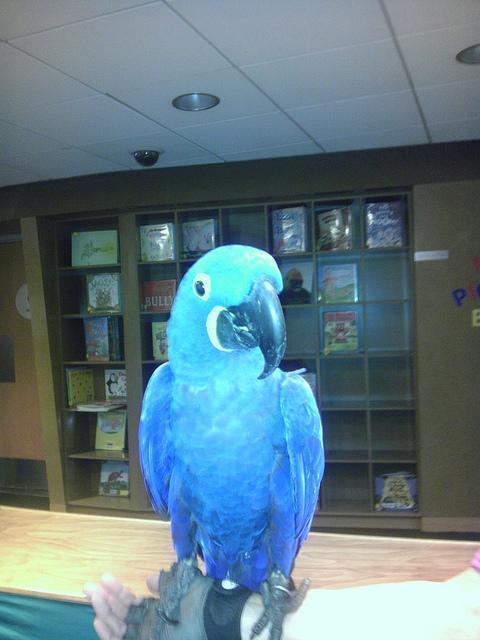Is "The person is touching the bird." an appropriate description for the image?
Answer yes or no. Yes. 